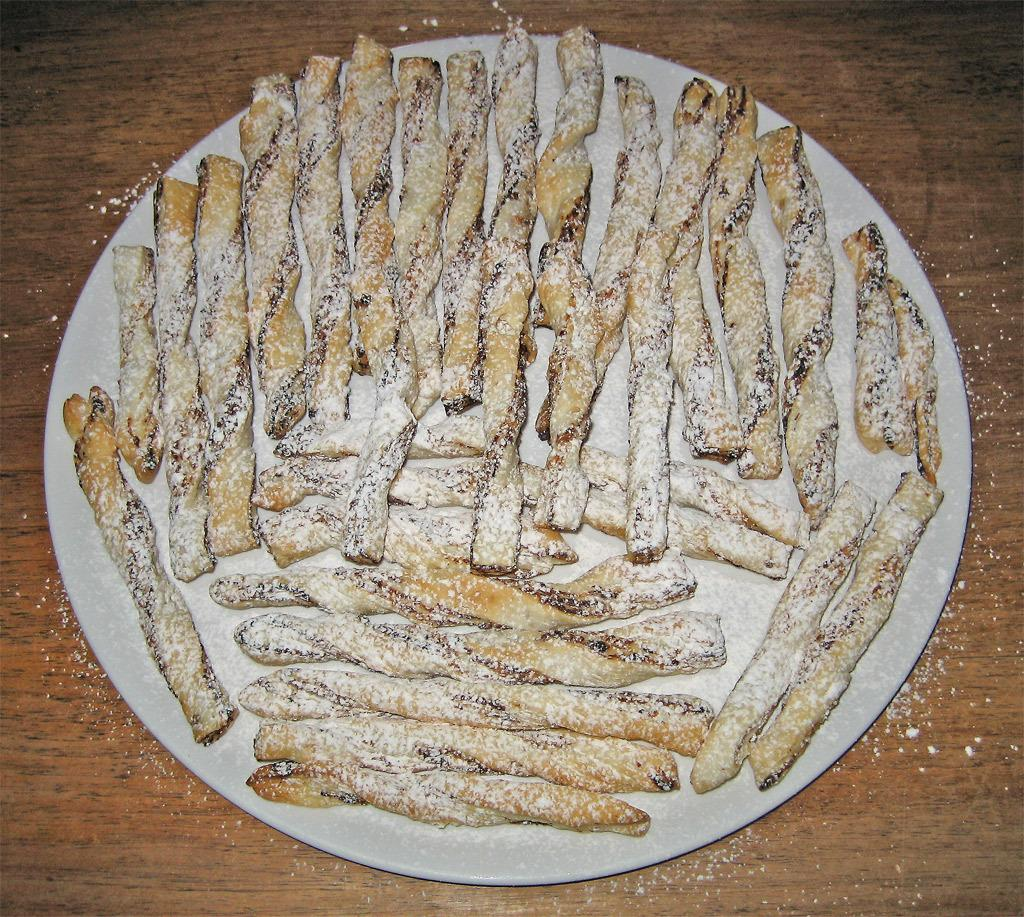What is on the plate in the image? There is food on a plate in the image. What type of waste is visible in the image? There is no waste visible in the image; it only shows food on a plate. What material is the plate made of in the image? The material of the plate is not mentioned in the provided fact, so it cannot be determined from the image. 